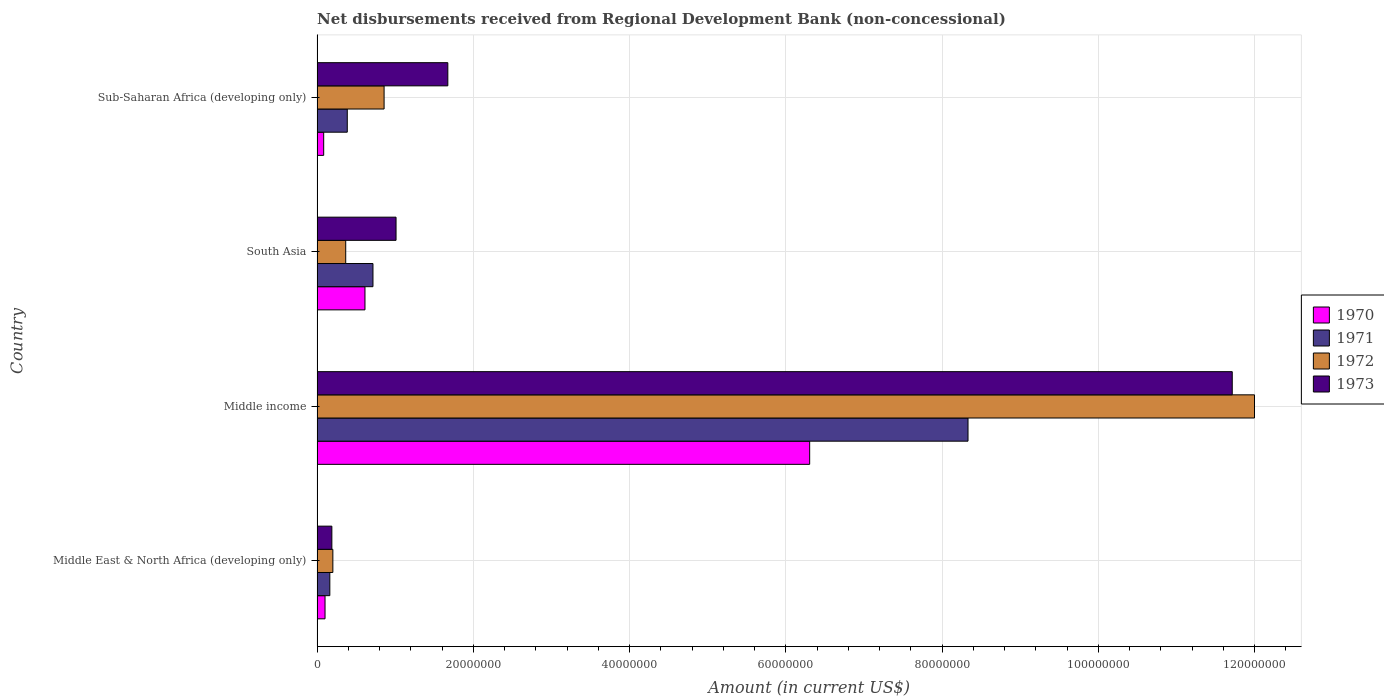How many groups of bars are there?
Your response must be concise. 4. Are the number of bars per tick equal to the number of legend labels?
Provide a succinct answer. Yes. How many bars are there on the 2nd tick from the bottom?
Provide a succinct answer. 4. What is the label of the 1st group of bars from the top?
Provide a short and direct response. Sub-Saharan Africa (developing only). In how many cases, is the number of bars for a given country not equal to the number of legend labels?
Your answer should be very brief. 0. What is the amount of disbursements received from Regional Development Bank in 1971 in Sub-Saharan Africa (developing only)?
Offer a terse response. 3.87e+06. Across all countries, what is the maximum amount of disbursements received from Regional Development Bank in 1971?
Give a very brief answer. 8.33e+07. Across all countries, what is the minimum amount of disbursements received from Regional Development Bank in 1972?
Keep it short and to the point. 2.02e+06. In which country was the amount of disbursements received from Regional Development Bank in 1971 maximum?
Your answer should be compact. Middle income. In which country was the amount of disbursements received from Regional Development Bank in 1970 minimum?
Give a very brief answer. Sub-Saharan Africa (developing only). What is the total amount of disbursements received from Regional Development Bank in 1972 in the graph?
Ensure brevity in your answer.  1.34e+08. What is the difference between the amount of disbursements received from Regional Development Bank in 1973 in Middle income and that in South Asia?
Your response must be concise. 1.07e+08. What is the difference between the amount of disbursements received from Regional Development Bank in 1972 in South Asia and the amount of disbursements received from Regional Development Bank in 1971 in Sub-Saharan Africa (developing only)?
Your answer should be very brief. -2.00e+05. What is the average amount of disbursements received from Regional Development Bank in 1971 per country?
Offer a very short reply. 2.40e+07. What is the difference between the amount of disbursements received from Regional Development Bank in 1971 and amount of disbursements received from Regional Development Bank in 1973 in South Asia?
Your response must be concise. -2.95e+06. What is the ratio of the amount of disbursements received from Regional Development Bank in 1973 in South Asia to that in Sub-Saharan Africa (developing only)?
Offer a very short reply. 0.6. Is the amount of disbursements received from Regional Development Bank in 1970 in Middle East & North Africa (developing only) less than that in South Asia?
Offer a very short reply. Yes. What is the difference between the highest and the second highest amount of disbursements received from Regional Development Bank in 1972?
Keep it short and to the point. 1.11e+08. What is the difference between the highest and the lowest amount of disbursements received from Regional Development Bank in 1971?
Your answer should be very brief. 8.17e+07. Is the sum of the amount of disbursements received from Regional Development Bank in 1971 in Middle East & North Africa (developing only) and Middle income greater than the maximum amount of disbursements received from Regional Development Bank in 1972 across all countries?
Provide a succinct answer. No. What does the 3rd bar from the bottom in Middle East & North Africa (developing only) represents?
Ensure brevity in your answer.  1972. Is it the case that in every country, the sum of the amount of disbursements received from Regional Development Bank in 1973 and amount of disbursements received from Regional Development Bank in 1972 is greater than the amount of disbursements received from Regional Development Bank in 1971?
Provide a short and direct response. Yes. How many bars are there?
Your answer should be very brief. 16. Are all the bars in the graph horizontal?
Make the answer very short. Yes. Does the graph contain any zero values?
Your answer should be compact. No. Does the graph contain grids?
Keep it short and to the point. Yes. How many legend labels are there?
Ensure brevity in your answer.  4. What is the title of the graph?
Ensure brevity in your answer.  Net disbursements received from Regional Development Bank (non-concessional). What is the label or title of the Y-axis?
Give a very brief answer. Country. What is the Amount (in current US$) of 1970 in Middle East & North Africa (developing only)?
Your answer should be very brief. 1.02e+06. What is the Amount (in current US$) of 1971 in Middle East & North Africa (developing only)?
Provide a short and direct response. 1.64e+06. What is the Amount (in current US$) in 1972 in Middle East & North Africa (developing only)?
Make the answer very short. 2.02e+06. What is the Amount (in current US$) of 1973 in Middle East & North Africa (developing only)?
Your answer should be compact. 1.90e+06. What is the Amount (in current US$) in 1970 in Middle income?
Offer a terse response. 6.31e+07. What is the Amount (in current US$) in 1971 in Middle income?
Offer a terse response. 8.33e+07. What is the Amount (in current US$) in 1972 in Middle income?
Give a very brief answer. 1.20e+08. What is the Amount (in current US$) in 1973 in Middle income?
Offer a terse response. 1.17e+08. What is the Amount (in current US$) of 1970 in South Asia?
Provide a succinct answer. 6.13e+06. What is the Amount (in current US$) of 1971 in South Asia?
Offer a terse response. 7.16e+06. What is the Amount (in current US$) of 1972 in South Asia?
Provide a short and direct response. 3.67e+06. What is the Amount (in current US$) in 1973 in South Asia?
Your answer should be very brief. 1.01e+07. What is the Amount (in current US$) of 1970 in Sub-Saharan Africa (developing only)?
Give a very brief answer. 8.50e+05. What is the Amount (in current US$) in 1971 in Sub-Saharan Africa (developing only)?
Make the answer very short. 3.87e+06. What is the Amount (in current US$) in 1972 in Sub-Saharan Africa (developing only)?
Make the answer very short. 8.58e+06. What is the Amount (in current US$) in 1973 in Sub-Saharan Africa (developing only)?
Offer a very short reply. 1.67e+07. Across all countries, what is the maximum Amount (in current US$) of 1970?
Your answer should be very brief. 6.31e+07. Across all countries, what is the maximum Amount (in current US$) of 1971?
Provide a short and direct response. 8.33e+07. Across all countries, what is the maximum Amount (in current US$) in 1972?
Make the answer very short. 1.20e+08. Across all countries, what is the maximum Amount (in current US$) of 1973?
Provide a succinct answer. 1.17e+08. Across all countries, what is the minimum Amount (in current US$) in 1970?
Provide a short and direct response. 8.50e+05. Across all countries, what is the minimum Amount (in current US$) in 1971?
Provide a short and direct response. 1.64e+06. Across all countries, what is the minimum Amount (in current US$) of 1972?
Offer a very short reply. 2.02e+06. Across all countries, what is the minimum Amount (in current US$) of 1973?
Offer a very short reply. 1.90e+06. What is the total Amount (in current US$) of 1970 in the graph?
Your response must be concise. 7.11e+07. What is the total Amount (in current US$) of 1971 in the graph?
Provide a succinct answer. 9.60e+07. What is the total Amount (in current US$) in 1972 in the graph?
Offer a terse response. 1.34e+08. What is the total Amount (in current US$) of 1973 in the graph?
Give a very brief answer. 1.46e+08. What is the difference between the Amount (in current US$) in 1970 in Middle East & North Africa (developing only) and that in Middle income?
Your response must be concise. -6.20e+07. What is the difference between the Amount (in current US$) in 1971 in Middle East & North Africa (developing only) and that in Middle income?
Ensure brevity in your answer.  -8.17e+07. What is the difference between the Amount (in current US$) in 1972 in Middle East & North Africa (developing only) and that in Middle income?
Ensure brevity in your answer.  -1.18e+08. What is the difference between the Amount (in current US$) of 1973 in Middle East & North Africa (developing only) and that in Middle income?
Offer a terse response. -1.15e+08. What is the difference between the Amount (in current US$) in 1970 in Middle East & North Africa (developing only) and that in South Asia?
Your answer should be very brief. -5.11e+06. What is the difference between the Amount (in current US$) of 1971 in Middle East & North Africa (developing only) and that in South Asia?
Your answer should be compact. -5.52e+06. What is the difference between the Amount (in current US$) in 1972 in Middle East & North Africa (developing only) and that in South Asia?
Provide a succinct answer. -1.64e+06. What is the difference between the Amount (in current US$) of 1973 in Middle East & North Africa (developing only) and that in South Asia?
Offer a very short reply. -8.22e+06. What is the difference between the Amount (in current US$) in 1970 in Middle East & North Africa (developing only) and that in Sub-Saharan Africa (developing only)?
Provide a short and direct response. 1.71e+05. What is the difference between the Amount (in current US$) in 1971 in Middle East & North Africa (developing only) and that in Sub-Saharan Africa (developing only)?
Ensure brevity in your answer.  -2.23e+06. What is the difference between the Amount (in current US$) of 1972 in Middle East & North Africa (developing only) and that in Sub-Saharan Africa (developing only)?
Your response must be concise. -6.56e+06. What is the difference between the Amount (in current US$) of 1973 in Middle East & North Africa (developing only) and that in Sub-Saharan Africa (developing only)?
Keep it short and to the point. -1.48e+07. What is the difference between the Amount (in current US$) of 1970 in Middle income and that in South Asia?
Offer a terse response. 5.69e+07. What is the difference between the Amount (in current US$) in 1971 in Middle income and that in South Asia?
Provide a succinct answer. 7.62e+07. What is the difference between the Amount (in current US$) of 1972 in Middle income and that in South Asia?
Offer a very short reply. 1.16e+08. What is the difference between the Amount (in current US$) of 1973 in Middle income and that in South Asia?
Provide a succinct answer. 1.07e+08. What is the difference between the Amount (in current US$) of 1970 in Middle income and that in Sub-Saharan Africa (developing only)?
Ensure brevity in your answer.  6.22e+07. What is the difference between the Amount (in current US$) of 1971 in Middle income and that in Sub-Saharan Africa (developing only)?
Give a very brief answer. 7.95e+07. What is the difference between the Amount (in current US$) of 1972 in Middle income and that in Sub-Saharan Africa (developing only)?
Offer a very short reply. 1.11e+08. What is the difference between the Amount (in current US$) in 1973 in Middle income and that in Sub-Saharan Africa (developing only)?
Ensure brevity in your answer.  1.00e+08. What is the difference between the Amount (in current US$) in 1970 in South Asia and that in Sub-Saharan Africa (developing only)?
Your answer should be compact. 5.28e+06. What is the difference between the Amount (in current US$) in 1971 in South Asia and that in Sub-Saharan Africa (developing only)?
Keep it short and to the point. 3.29e+06. What is the difference between the Amount (in current US$) of 1972 in South Asia and that in Sub-Saharan Africa (developing only)?
Keep it short and to the point. -4.91e+06. What is the difference between the Amount (in current US$) of 1973 in South Asia and that in Sub-Saharan Africa (developing only)?
Ensure brevity in your answer.  -6.63e+06. What is the difference between the Amount (in current US$) of 1970 in Middle East & North Africa (developing only) and the Amount (in current US$) of 1971 in Middle income?
Make the answer very short. -8.23e+07. What is the difference between the Amount (in current US$) of 1970 in Middle East & North Africa (developing only) and the Amount (in current US$) of 1972 in Middle income?
Provide a short and direct response. -1.19e+08. What is the difference between the Amount (in current US$) of 1970 in Middle East & North Africa (developing only) and the Amount (in current US$) of 1973 in Middle income?
Make the answer very short. -1.16e+08. What is the difference between the Amount (in current US$) of 1971 in Middle East & North Africa (developing only) and the Amount (in current US$) of 1972 in Middle income?
Give a very brief answer. -1.18e+08. What is the difference between the Amount (in current US$) of 1971 in Middle East & North Africa (developing only) and the Amount (in current US$) of 1973 in Middle income?
Offer a terse response. -1.16e+08. What is the difference between the Amount (in current US$) in 1972 in Middle East & North Africa (developing only) and the Amount (in current US$) in 1973 in Middle income?
Your response must be concise. -1.15e+08. What is the difference between the Amount (in current US$) in 1970 in Middle East & North Africa (developing only) and the Amount (in current US$) in 1971 in South Asia?
Offer a terse response. -6.14e+06. What is the difference between the Amount (in current US$) of 1970 in Middle East & North Africa (developing only) and the Amount (in current US$) of 1972 in South Asia?
Offer a terse response. -2.65e+06. What is the difference between the Amount (in current US$) of 1970 in Middle East & North Africa (developing only) and the Amount (in current US$) of 1973 in South Asia?
Offer a terse response. -9.09e+06. What is the difference between the Amount (in current US$) in 1971 in Middle East & North Africa (developing only) and the Amount (in current US$) in 1972 in South Asia?
Provide a short and direct response. -2.03e+06. What is the difference between the Amount (in current US$) in 1971 in Middle East & North Africa (developing only) and the Amount (in current US$) in 1973 in South Asia?
Ensure brevity in your answer.  -8.48e+06. What is the difference between the Amount (in current US$) in 1972 in Middle East & North Africa (developing only) and the Amount (in current US$) in 1973 in South Asia?
Ensure brevity in your answer.  -8.09e+06. What is the difference between the Amount (in current US$) in 1970 in Middle East & North Africa (developing only) and the Amount (in current US$) in 1971 in Sub-Saharan Africa (developing only)?
Keep it short and to the point. -2.85e+06. What is the difference between the Amount (in current US$) of 1970 in Middle East & North Africa (developing only) and the Amount (in current US$) of 1972 in Sub-Saharan Africa (developing only)?
Provide a succinct answer. -7.56e+06. What is the difference between the Amount (in current US$) in 1970 in Middle East & North Africa (developing only) and the Amount (in current US$) in 1973 in Sub-Saharan Africa (developing only)?
Your response must be concise. -1.57e+07. What is the difference between the Amount (in current US$) in 1971 in Middle East & North Africa (developing only) and the Amount (in current US$) in 1972 in Sub-Saharan Africa (developing only)?
Offer a terse response. -6.95e+06. What is the difference between the Amount (in current US$) of 1971 in Middle East & North Africa (developing only) and the Amount (in current US$) of 1973 in Sub-Saharan Africa (developing only)?
Offer a terse response. -1.51e+07. What is the difference between the Amount (in current US$) of 1972 in Middle East & North Africa (developing only) and the Amount (in current US$) of 1973 in Sub-Saharan Africa (developing only)?
Ensure brevity in your answer.  -1.47e+07. What is the difference between the Amount (in current US$) in 1970 in Middle income and the Amount (in current US$) in 1971 in South Asia?
Ensure brevity in your answer.  5.59e+07. What is the difference between the Amount (in current US$) of 1970 in Middle income and the Amount (in current US$) of 1972 in South Asia?
Your answer should be very brief. 5.94e+07. What is the difference between the Amount (in current US$) in 1970 in Middle income and the Amount (in current US$) in 1973 in South Asia?
Your answer should be compact. 5.29e+07. What is the difference between the Amount (in current US$) in 1971 in Middle income and the Amount (in current US$) in 1972 in South Asia?
Give a very brief answer. 7.97e+07. What is the difference between the Amount (in current US$) in 1971 in Middle income and the Amount (in current US$) in 1973 in South Asia?
Make the answer very short. 7.32e+07. What is the difference between the Amount (in current US$) of 1972 in Middle income and the Amount (in current US$) of 1973 in South Asia?
Ensure brevity in your answer.  1.10e+08. What is the difference between the Amount (in current US$) in 1970 in Middle income and the Amount (in current US$) in 1971 in Sub-Saharan Africa (developing only)?
Offer a very short reply. 5.92e+07. What is the difference between the Amount (in current US$) in 1970 in Middle income and the Amount (in current US$) in 1972 in Sub-Saharan Africa (developing only)?
Provide a short and direct response. 5.45e+07. What is the difference between the Amount (in current US$) in 1970 in Middle income and the Amount (in current US$) in 1973 in Sub-Saharan Africa (developing only)?
Provide a short and direct response. 4.63e+07. What is the difference between the Amount (in current US$) in 1971 in Middle income and the Amount (in current US$) in 1972 in Sub-Saharan Africa (developing only)?
Provide a short and direct response. 7.47e+07. What is the difference between the Amount (in current US$) in 1971 in Middle income and the Amount (in current US$) in 1973 in Sub-Saharan Africa (developing only)?
Make the answer very short. 6.66e+07. What is the difference between the Amount (in current US$) in 1972 in Middle income and the Amount (in current US$) in 1973 in Sub-Saharan Africa (developing only)?
Offer a terse response. 1.03e+08. What is the difference between the Amount (in current US$) of 1970 in South Asia and the Amount (in current US$) of 1971 in Sub-Saharan Africa (developing only)?
Your response must be concise. 2.26e+06. What is the difference between the Amount (in current US$) of 1970 in South Asia and the Amount (in current US$) of 1972 in Sub-Saharan Africa (developing only)?
Make the answer very short. -2.45e+06. What is the difference between the Amount (in current US$) of 1970 in South Asia and the Amount (in current US$) of 1973 in Sub-Saharan Africa (developing only)?
Give a very brief answer. -1.06e+07. What is the difference between the Amount (in current US$) of 1971 in South Asia and the Amount (in current US$) of 1972 in Sub-Saharan Africa (developing only)?
Make the answer very short. -1.42e+06. What is the difference between the Amount (in current US$) of 1971 in South Asia and the Amount (in current US$) of 1973 in Sub-Saharan Africa (developing only)?
Your response must be concise. -9.58e+06. What is the difference between the Amount (in current US$) in 1972 in South Asia and the Amount (in current US$) in 1973 in Sub-Saharan Africa (developing only)?
Offer a very short reply. -1.31e+07. What is the average Amount (in current US$) of 1970 per country?
Your answer should be compact. 1.78e+07. What is the average Amount (in current US$) of 1971 per country?
Your answer should be compact. 2.40e+07. What is the average Amount (in current US$) in 1972 per country?
Provide a short and direct response. 3.36e+07. What is the average Amount (in current US$) in 1973 per country?
Provide a short and direct response. 3.65e+07. What is the difference between the Amount (in current US$) in 1970 and Amount (in current US$) in 1971 in Middle East & North Africa (developing only)?
Make the answer very short. -6.14e+05. What is the difference between the Amount (in current US$) in 1970 and Amount (in current US$) in 1972 in Middle East & North Africa (developing only)?
Your answer should be compact. -1.00e+06. What is the difference between the Amount (in current US$) in 1970 and Amount (in current US$) in 1973 in Middle East & North Africa (developing only)?
Ensure brevity in your answer.  -8.75e+05. What is the difference between the Amount (in current US$) of 1971 and Amount (in current US$) of 1972 in Middle East & North Africa (developing only)?
Keep it short and to the point. -3.89e+05. What is the difference between the Amount (in current US$) in 1971 and Amount (in current US$) in 1973 in Middle East & North Africa (developing only)?
Ensure brevity in your answer.  -2.61e+05. What is the difference between the Amount (in current US$) of 1972 and Amount (in current US$) of 1973 in Middle East & North Africa (developing only)?
Your response must be concise. 1.28e+05. What is the difference between the Amount (in current US$) in 1970 and Amount (in current US$) in 1971 in Middle income?
Offer a very short reply. -2.03e+07. What is the difference between the Amount (in current US$) in 1970 and Amount (in current US$) in 1972 in Middle income?
Offer a very short reply. -5.69e+07. What is the difference between the Amount (in current US$) in 1970 and Amount (in current US$) in 1973 in Middle income?
Your response must be concise. -5.41e+07. What is the difference between the Amount (in current US$) of 1971 and Amount (in current US$) of 1972 in Middle income?
Your answer should be compact. -3.67e+07. What is the difference between the Amount (in current US$) in 1971 and Amount (in current US$) in 1973 in Middle income?
Your answer should be compact. -3.38e+07. What is the difference between the Amount (in current US$) in 1972 and Amount (in current US$) in 1973 in Middle income?
Provide a short and direct response. 2.85e+06. What is the difference between the Amount (in current US$) in 1970 and Amount (in current US$) in 1971 in South Asia?
Your answer should be compact. -1.02e+06. What is the difference between the Amount (in current US$) of 1970 and Amount (in current US$) of 1972 in South Asia?
Make the answer very short. 2.46e+06. What is the difference between the Amount (in current US$) in 1970 and Amount (in current US$) in 1973 in South Asia?
Provide a short and direct response. -3.98e+06. What is the difference between the Amount (in current US$) of 1971 and Amount (in current US$) of 1972 in South Asia?
Your answer should be very brief. 3.49e+06. What is the difference between the Amount (in current US$) of 1971 and Amount (in current US$) of 1973 in South Asia?
Keep it short and to the point. -2.95e+06. What is the difference between the Amount (in current US$) of 1972 and Amount (in current US$) of 1973 in South Asia?
Your response must be concise. -6.44e+06. What is the difference between the Amount (in current US$) in 1970 and Amount (in current US$) in 1971 in Sub-Saharan Africa (developing only)?
Provide a short and direct response. -3.02e+06. What is the difference between the Amount (in current US$) in 1970 and Amount (in current US$) in 1972 in Sub-Saharan Africa (developing only)?
Offer a very short reply. -7.73e+06. What is the difference between the Amount (in current US$) of 1970 and Amount (in current US$) of 1973 in Sub-Saharan Africa (developing only)?
Your answer should be compact. -1.59e+07. What is the difference between the Amount (in current US$) in 1971 and Amount (in current US$) in 1972 in Sub-Saharan Africa (developing only)?
Offer a terse response. -4.71e+06. What is the difference between the Amount (in current US$) in 1971 and Amount (in current US$) in 1973 in Sub-Saharan Africa (developing only)?
Ensure brevity in your answer.  -1.29e+07. What is the difference between the Amount (in current US$) in 1972 and Amount (in current US$) in 1973 in Sub-Saharan Africa (developing only)?
Offer a very short reply. -8.16e+06. What is the ratio of the Amount (in current US$) of 1970 in Middle East & North Africa (developing only) to that in Middle income?
Give a very brief answer. 0.02. What is the ratio of the Amount (in current US$) of 1971 in Middle East & North Africa (developing only) to that in Middle income?
Keep it short and to the point. 0.02. What is the ratio of the Amount (in current US$) of 1972 in Middle East & North Africa (developing only) to that in Middle income?
Your answer should be compact. 0.02. What is the ratio of the Amount (in current US$) of 1973 in Middle East & North Africa (developing only) to that in Middle income?
Your answer should be very brief. 0.02. What is the ratio of the Amount (in current US$) of 1970 in Middle East & North Africa (developing only) to that in South Asia?
Your answer should be compact. 0.17. What is the ratio of the Amount (in current US$) in 1971 in Middle East & North Africa (developing only) to that in South Asia?
Your answer should be very brief. 0.23. What is the ratio of the Amount (in current US$) in 1972 in Middle East & North Africa (developing only) to that in South Asia?
Your response must be concise. 0.55. What is the ratio of the Amount (in current US$) in 1973 in Middle East & North Africa (developing only) to that in South Asia?
Provide a succinct answer. 0.19. What is the ratio of the Amount (in current US$) of 1970 in Middle East & North Africa (developing only) to that in Sub-Saharan Africa (developing only)?
Give a very brief answer. 1.2. What is the ratio of the Amount (in current US$) of 1971 in Middle East & North Africa (developing only) to that in Sub-Saharan Africa (developing only)?
Your answer should be very brief. 0.42. What is the ratio of the Amount (in current US$) in 1972 in Middle East & North Africa (developing only) to that in Sub-Saharan Africa (developing only)?
Give a very brief answer. 0.24. What is the ratio of the Amount (in current US$) in 1973 in Middle East & North Africa (developing only) to that in Sub-Saharan Africa (developing only)?
Offer a terse response. 0.11. What is the ratio of the Amount (in current US$) of 1970 in Middle income to that in South Asia?
Keep it short and to the point. 10.28. What is the ratio of the Amount (in current US$) in 1971 in Middle income to that in South Asia?
Your response must be concise. 11.64. What is the ratio of the Amount (in current US$) in 1972 in Middle income to that in South Asia?
Provide a short and direct response. 32.71. What is the ratio of the Amount (in current US$) in 1973 in Middle income to that in South Asia?
Give a very brief answer. 11.58. What is the ratio of the Amount (in current US$) of 1970 in Middle income to that in Sub-Saharan Africa (developing only)?
Ensure brevity in your answer.  74.18. What is the ratio of the Amount (in current US$) in 1971 in Middle income to that in Sub-Saharan Africa (developing only)?
Your answer should be very brief. 21.54. What is the ratio of the Amount (in current US$) of 1972 in Middle income to that in Sub-Saharan Africa (developing only)?
Provide a succinct answer. 13.98. What is the ratio of the Amount (in current US$) of 1973 in Middle income to that in Sub-Saharan Africa (developing only)?
Offer a terse response. 7. What is the ratio of the Amount (in current US$) of 1970 in South Asia to that in Sub-Saharan Africa (developing only)?
Provide a succinct answer. 7.22. What is the ratio of the Amount (in current US$) in 1971 in South Asia to that in Sub-Saharan Africa (developing only)?
Offer a terse response. 1.85. What is the ratio of the Amount (in current US$) of 1972 in South Asia to that in Sub-Saharan Africa (developing only)?
Offer a terse response. 0.43. What is the ratio of the Amount (in current US$) of 1973 in South Asia to that in Sub-Saharan Africa (developing only)?
Keep it short and to the point. 0.6. What is the difference between the highest and the second highest Amount (in current US$) in 1970?
Keep it short and to the point. 5.69e+07. What is the difference between the highest and the second highest Amount (in current US$) in 1971?
Provide a succinct answer. 7.62e+07. What is the difference between the highest and the second highest Amount (in current US$) in 1972?
Your answer should be compact. 1.11e+08. What is the difference between the highest and the second highest Amount (in current US$) of 1973?
Provide a succinct answer. 1.00e+08. What is the difference between the highest and the lowest Amount (in current US$) in 1970?
Your response must be concise. 6.22e+07. What is the difference between the highest and the lowest Amount (in current US$) of 1971?
Give a very brief answer. 8.17e+07. What is the difference between the highest and the lowest Amount (in current US$) of 1972?
Provide a succinct answer. 1.18e+08. What is the difference between the highest and the lowest Amount (in current US$) in 1973?
Your response must be concise. 1.15e+08. 